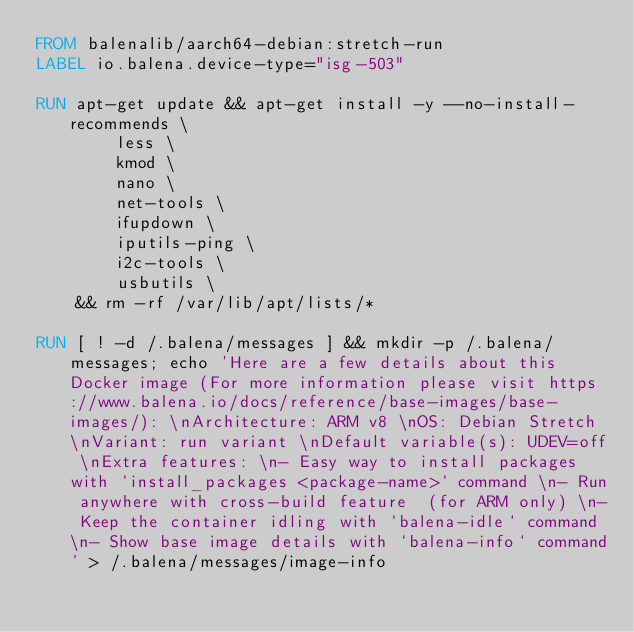<code> <loc_0><loc_0><loc_500><loc_500><_Dockerfile_>FROM balenalib/aarch64-debian:stretch-run
LABEL io.balena.device-type="isg-503"

RUN apt-get update && apt-get install -y --no-install-recommends \
		less \
		kmod \
		nano \
		net-tools \
		ifupdown \
		iputils-ping \
		i2c-tools \
		usbutils \
	&& rm -rf /var/lib/apt/lists/*

RUN [ ! -d /.balena/messages ] && mkdir -p /.balena/messages; echo 'Here are a few details about this Docker image (For more information please visit https://www.balena.io/docs/reference/base-images/base-images/): \nArchitecture: ARM v8 \nOS: Debian Stretch \nVariant: run variant \nDefault variable(s): UDEV=off \nExtra features: \n- Easy way to install packages with `install_packages <package-name>` command \n- Run anywhere with cross-build feature  (for ARM only) \n- Keep the container idling with `balena-idle` command \n- Show base image details with `balena-info` command' > /.balena/messages/image-info</code> 